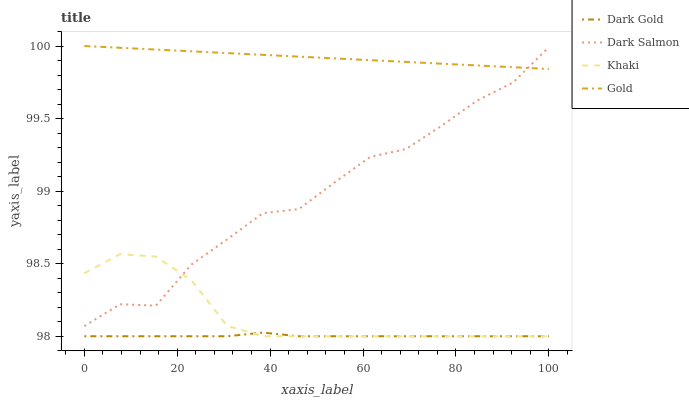Does Dark Gold have the minimum area under the curve?
Answer yes or no. Yes. Does Gold have the maximum area under the curve?
Answer yes or no. Yes. Does Dark Salmon have the minimum area under the curve?
Answer yes or no. No. Does Dark Salmon have the maximum area under the curve?
Answer yes or no. No. Is Gold the smoothest?
Answer yes or no. Yes. Is Dark Salmon the roughest?
Answer yes or no. Yes. Is Dark Salmon the smoothest?
Answer yes or no. No. Is Gold the roughest?
Answer yes or no. No. Does Khaki have the lowest value?
Answer yes or no. Yes. Does Dark Salmon have the lowest value?
Answer yes or no. No. Does Gold have the highest value?
Answer yes or no. Yes. Does Dark Salmon have the highest value?
Answer yes or no. No. Is Dark Gold less than Gold?
Answer yes or no. Yes. Is Gold greater than Dark Gold?
Answer yes or no. Yes. Does Dark Gold intersect Khaki?
Answer yes or no. Yes. Is Dark Gold less than Khaki?
Answer yes or no. No. Is Dark Gold greater than Khaki?
Answer yes or no. No. Does Dark Gold intersect Gold?
Answer yes or no. No. 